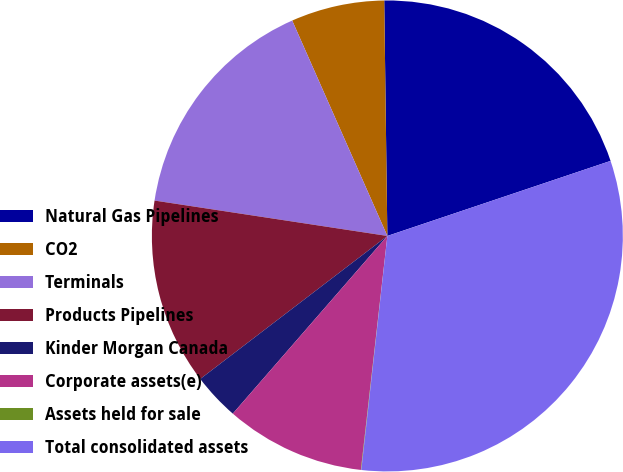<chart> <loc_0><loc_0><loc_500><loc_500><pie_chart><fcel>Natural Gas Pipelines<fcel>CO2<fcel>Terminals<fcel>Products Pipelines<fcel>Kinder Morgan Canada<fcel>Corporate assets(e)<fcel>Assets held for sale<fcel>Total consolidated assets<nl><fcel>20.05%<fcel>6.41%<fcel>15.98%<fcel>12.79%<fcel>3.22%<fcel>9.6%<fcel>0.03%<fcel>31.93%<nl></chart> 